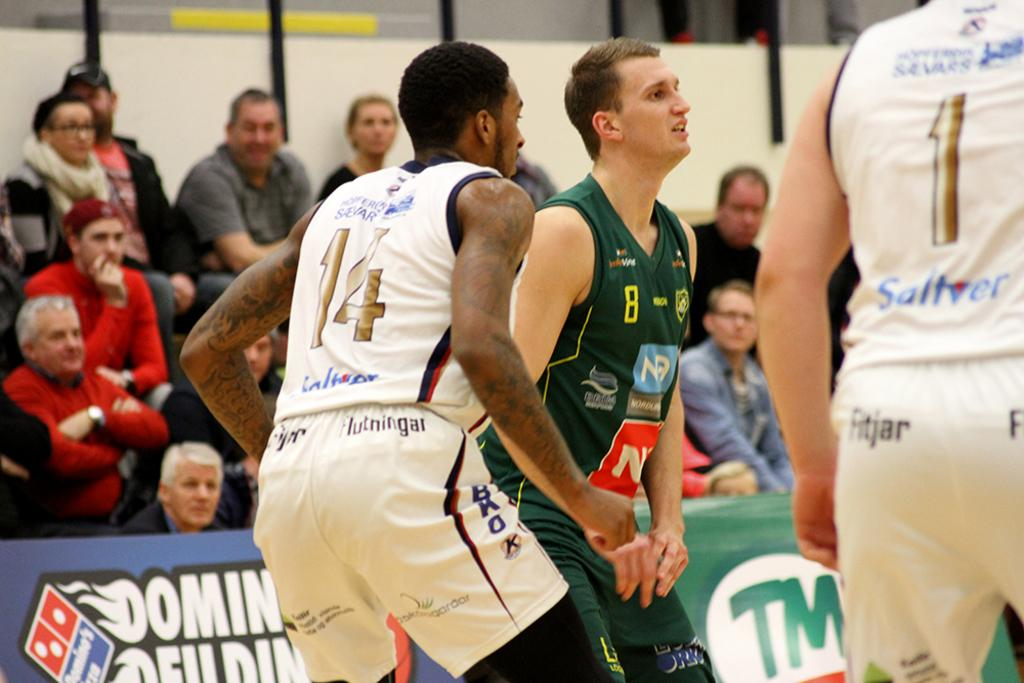<image>
Create a compact narrative representing the image presented. Basketball players play their game in front of a Dominos advertisement. 